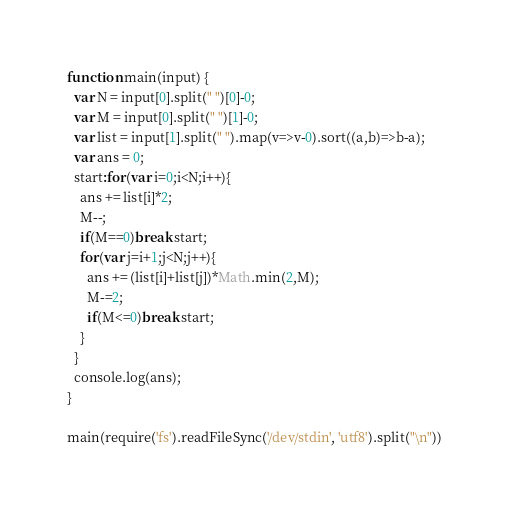Convert code to text. <code><loc_0><loc_0><loc_500><loc_500><_JavaScript_>function main(input) {
  var N = input[0].split(" ")[0]-0;
  var M = input[0].split(" ")[1]-0;
  var list = input[1].split(" ").map(v=>v-0).sort((a,b)=>b-a);
  var ans = 0;
  start:for(var i=0;i<N;i++){
    ans += list[i]*2;
    M--;
    if(M==0)break start;
    for(var j=i+1;j<N;j++){
      ans += (list[i]+list[j])*Math.min(2,M);
      M-=2;
      if(M<=0)break start;
    }
  }
  console.log(ans);
}

main(require('fs').readFileSync('/dev/stdin', 'utf8').split("\n"))
</code> 